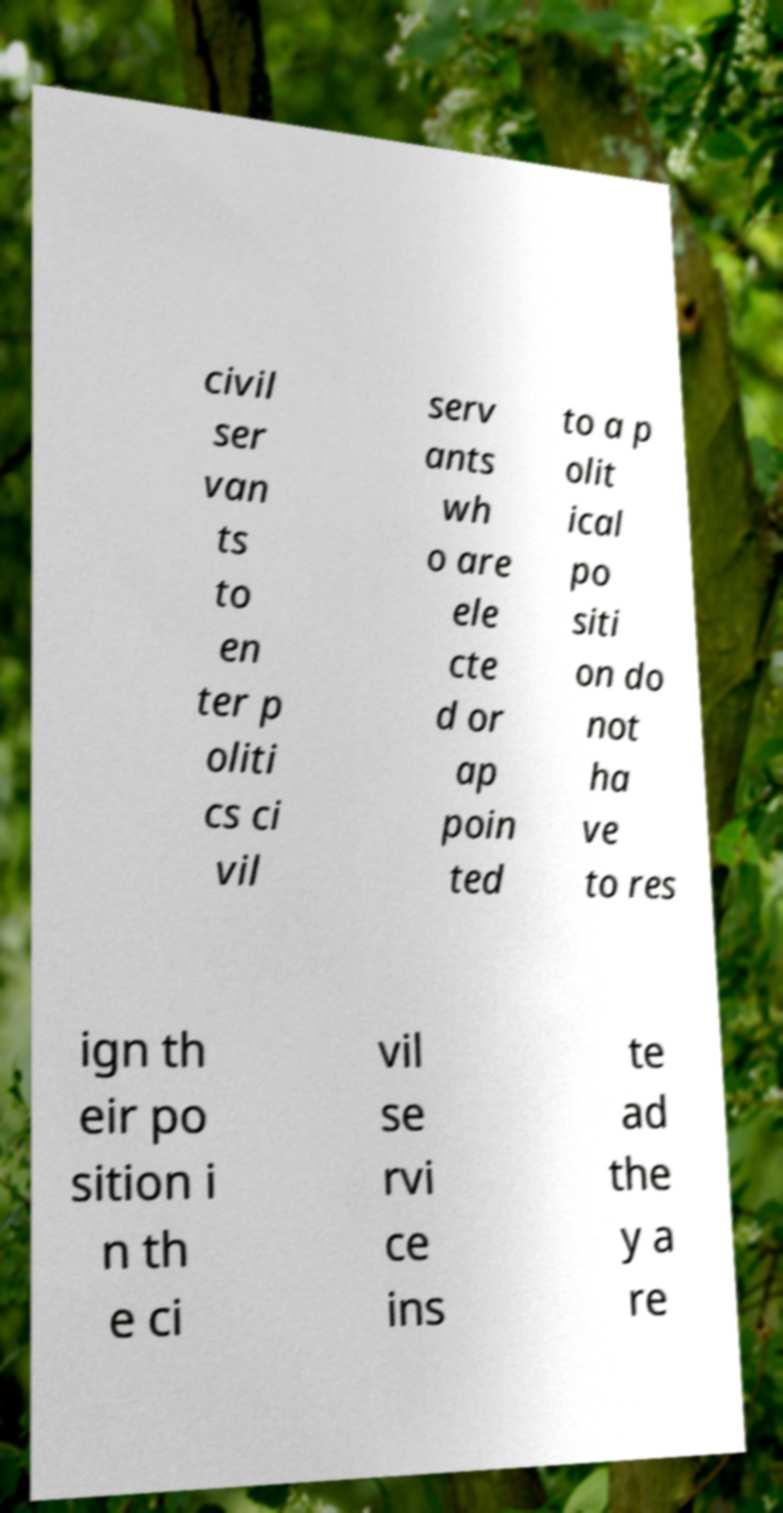What messages or text are displayed in this image? I need them in a readable, typed format. civil ser van ts to en ter p oliti cs ci vil serv ants wh o are ele cte d or ap poin ted to a p olit ical po siti on do not ha ve to res ign th eir po sition i n th e ci vil se rvi ce ins te ad the y a re 